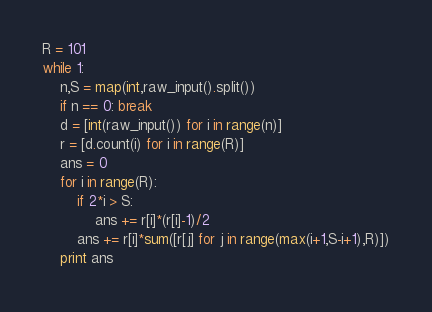<code> <loc_0><loc_0><loc_500><loc_500><_Python_>R = 101
while 1:
	n,S = map(int,raw_input().split())
	if n == 0: break
	d = [int(raw_input()) for i in range(n)]
	r = [d.count(i) for i in range(R)]
	ans = 0
	for i in range(R):
		if 2*i > S:
			ans += r[i]*(r[i]-1)/2
		ans += r[i]*sum([r[j] for j in range(max(i+1,S-i+1),R)])
	print ans</code> 